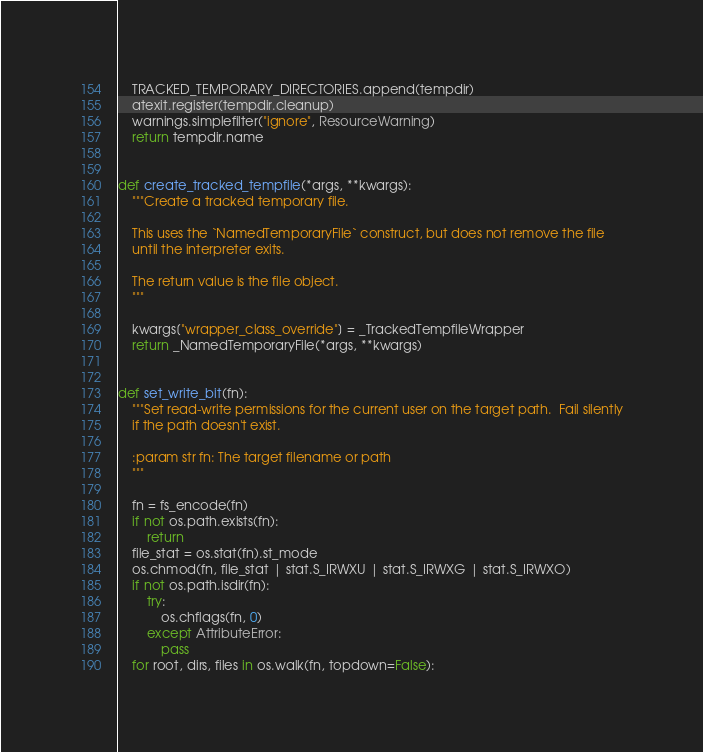Convert code to text. <code><loc_0><loc_0><loc_500><loc_500><_Python_>    TRACKED_TEMPORARY_DIRECTORIES.append(tempdir)
    atexit.register(tempdir.cleanup)
    warnings.simplefilter("ignore", ResourceWarning)
    return tempdir.name


def create_tracked_tempfile(*args, **kwargs):
    """Create a tracked temporary file.

    This uses the `NamedTemporaryFile` construct, but does not remove the file
    until the interpreter exits.

    The return value is the file object.
    """

    kwargs["wrapper_class_override"] = _TrackedTempfileWrapper
    return _NamedTemporaryFile(*args, **kwargs)


def set_write_bit(fn):
    """Set read-write permissions for the current user on the target path.  Fail silently
    if the path doesn't exist.

    :param str fn: The target filename or path
    """

    fn = fs_encode(fn)
    if not os.path.exists(fn):
        return
    file_stat = os.stat(fn).st_mode
    os.chmod(fn, file_stat | stat.S_IRWXU | stat.S_IRWXG | stat.S_IRWXO)
    if not os.path.isdir(fn):
        try:
            os.chflags(fn, 0)
        except AttributeError:
            pass
    for root, dirs, files in os.walk(fn, topdown=False):</code> 